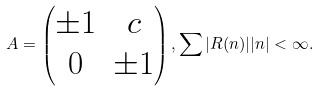Convert formula to latex. <formula><loc_0><loc_0><loc_500><loc_500>A = \begin{pmatrix} \pm 1 & c \\ 0 & \pm 1 \end{pmatrix} , \sum | R ( n ) | | n | < \infty .</formula> 